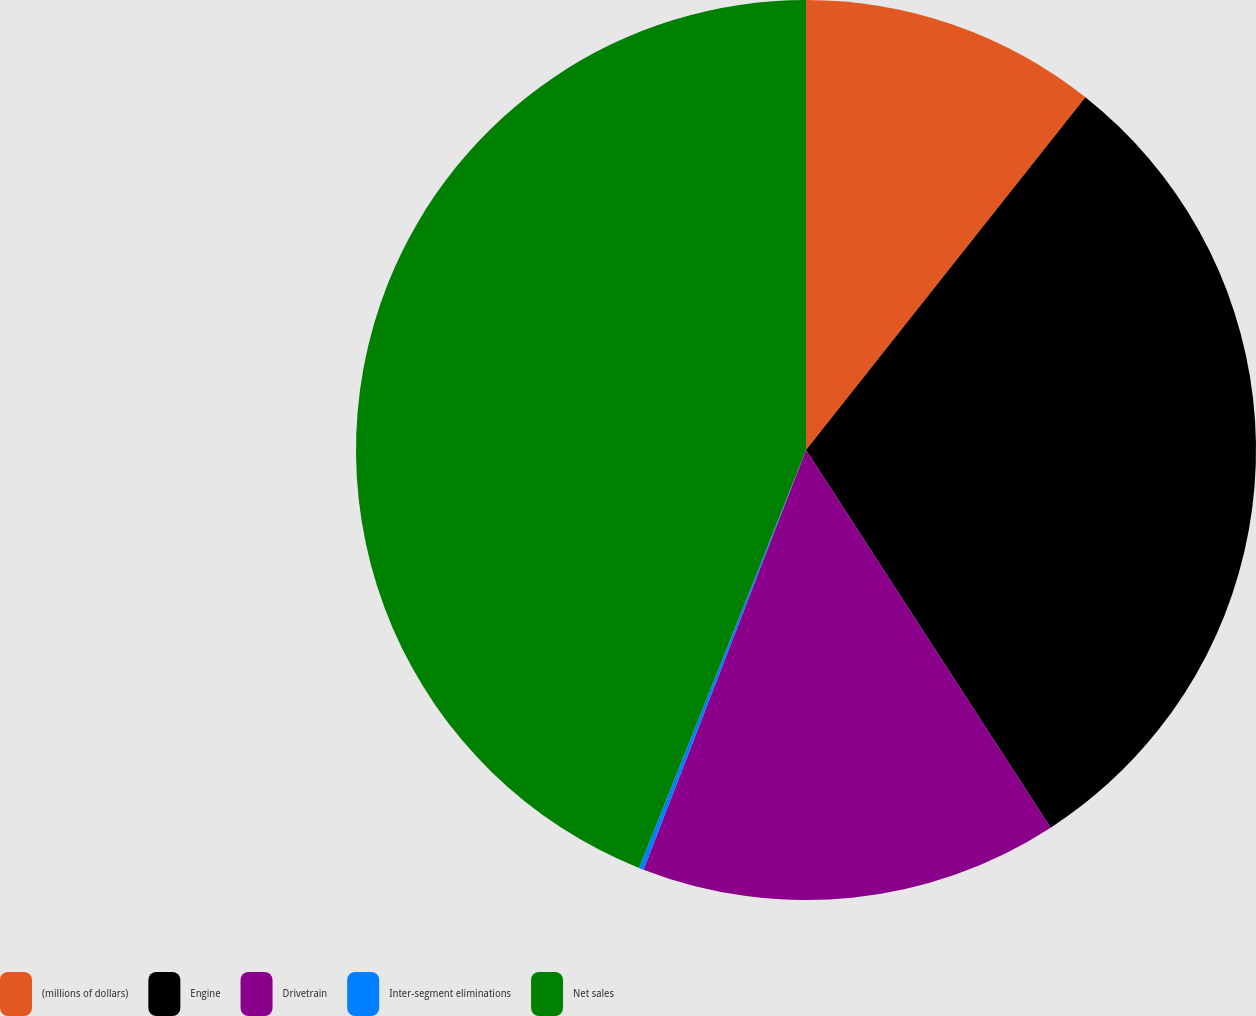Convert chart to OTSL. <chart><loc_0><loc_0><loc_500><loc_500><pie_chart><fcel>(millions of dollars)<fcel>Engine<fcel>Drivetrain<fcel>Inter-segment eliminations<fcel>Net sales<nl><fcel>10.66%<fcel>30.19%<fcel>15.03%<fcel>0.17%<fcel>43.95%<nl></chart> 